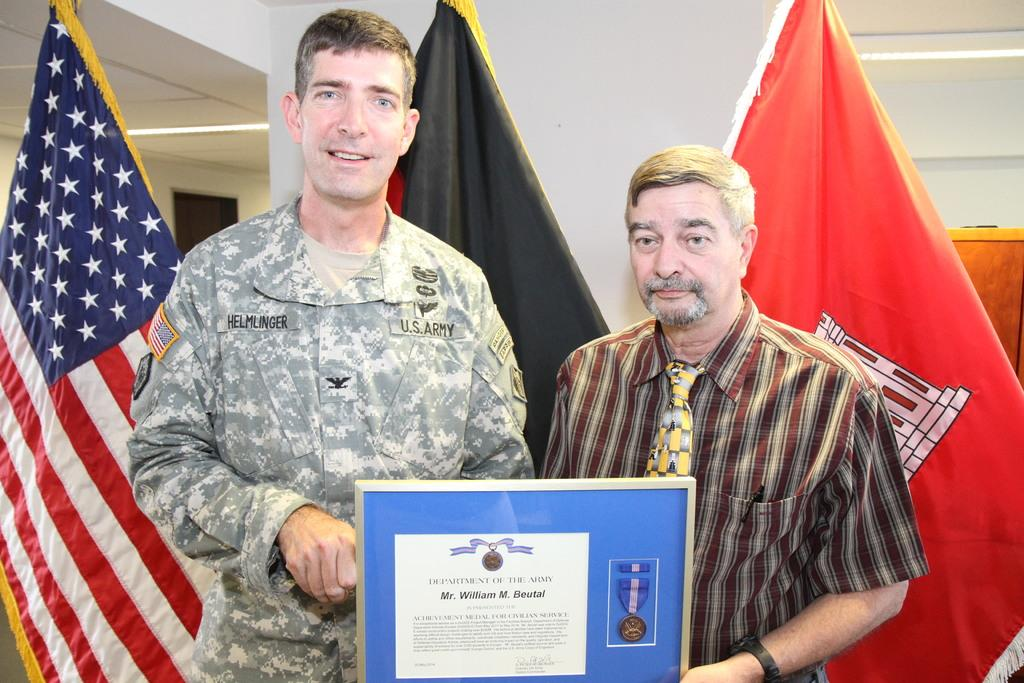How many people are present in the image? There are two people in the image. What can be seen in the image that might indicate an achievement or recognition? There is a certificate visible in the image. What can be seen in the background of the image? There are flags and a wall in the background of the image. Can you describe any objects visible in the background of the image? There are some objects in the background of the image. What type of stove is visible in the image? There is no stove present in the image. 